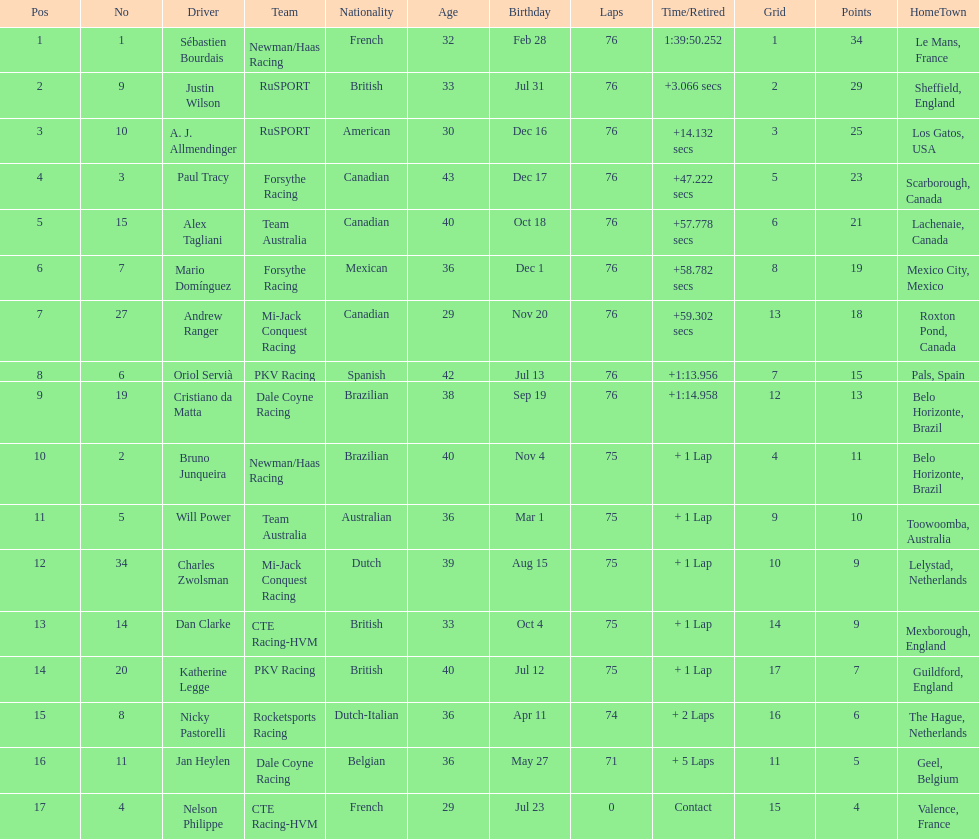Which driver has the least amount of points? Nelson Philippe. 